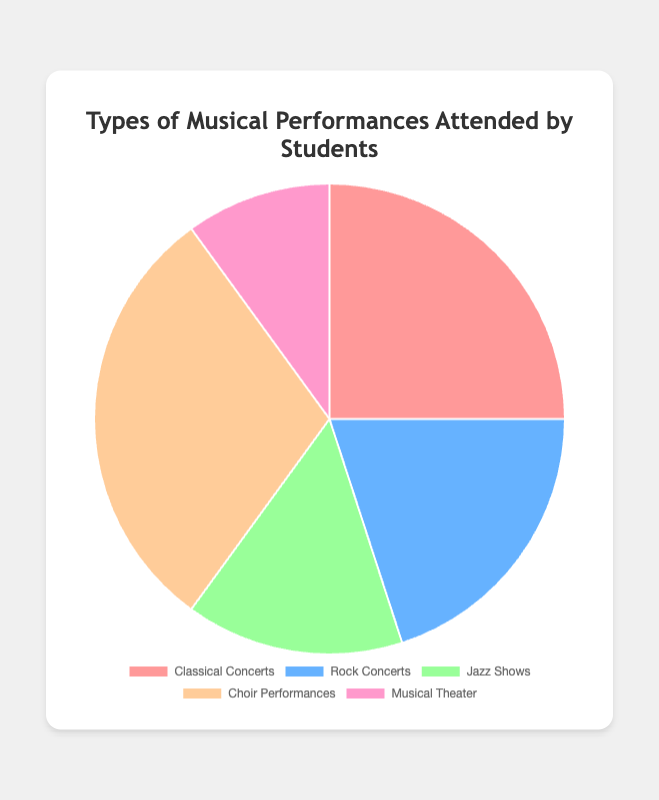What type of musical performance is attended by the highest percentage of students? The pie chart shows that Choir Performances account for 30% of the total, which is the highest percentage.
Answer: Choir Performances Which is attended by more students, Classical Concerts or Rock Concerts? Classical Concerts have a higher percentage of 25% compared to Rock Concerts, which have 20%.
Answer: Classical Concerts How much more popular are Choir Performances compared to Jazz Shows? Choir Performances account for 30%, while Jazz Shows account for 15%. The difference is 30% - 15% = 15%.
Answer: 15% If we combine the attendance percentages of Rock Concerts and Jazz Shows, what percentage do we get? Rock Concerts have 20% and Jazz Shows have 15%. Adding them together gives 20% + 15% = 35%.
Answer: 35% Which type of performance is the least attended by students? The pie chart shows Musical Theater with the lowest percentage at 10%.
Answer: Musical Theater What is the combined percentage of students attending Classical Concerts and Choir Performances? Classical Concerts make up 25% and Choir Performances account for 30%. Their combined percentage is 25% + 30% = 55%.
Answer: 55% Is the percentage of students attending Rock Concerts greater than those attending Classical Concerts? The percentage for Rock Concerts is 20%, which is less than the 25% for Classical Concerts.
Answer: No Which segment is represented by the second largest section of the pie chart? The second largest section corresponds to Classical Concerts with a 25% share, following Choir Performances.
Answer: Classical Concerts What percentage of the total student population attends non-Classical music performances (Rock Concerts, Jazz Shows, Choir Performances, Musical Theater)? Summing up the percentages of Rock Concerts (20%), Jazz Shows (15%), Choir Performances (30%), and Musical Theater (10%) gives 20% + 15% + 30% + 10% = 75%.
Answer: 75% 